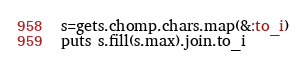Convert code to text. <code><loc_0><loc_0><loc_500><loc_500><_Ruby_>s=gets.chomp.chars.map(&:to_i)
puts s.fill(s.max).join.to_i</code> 